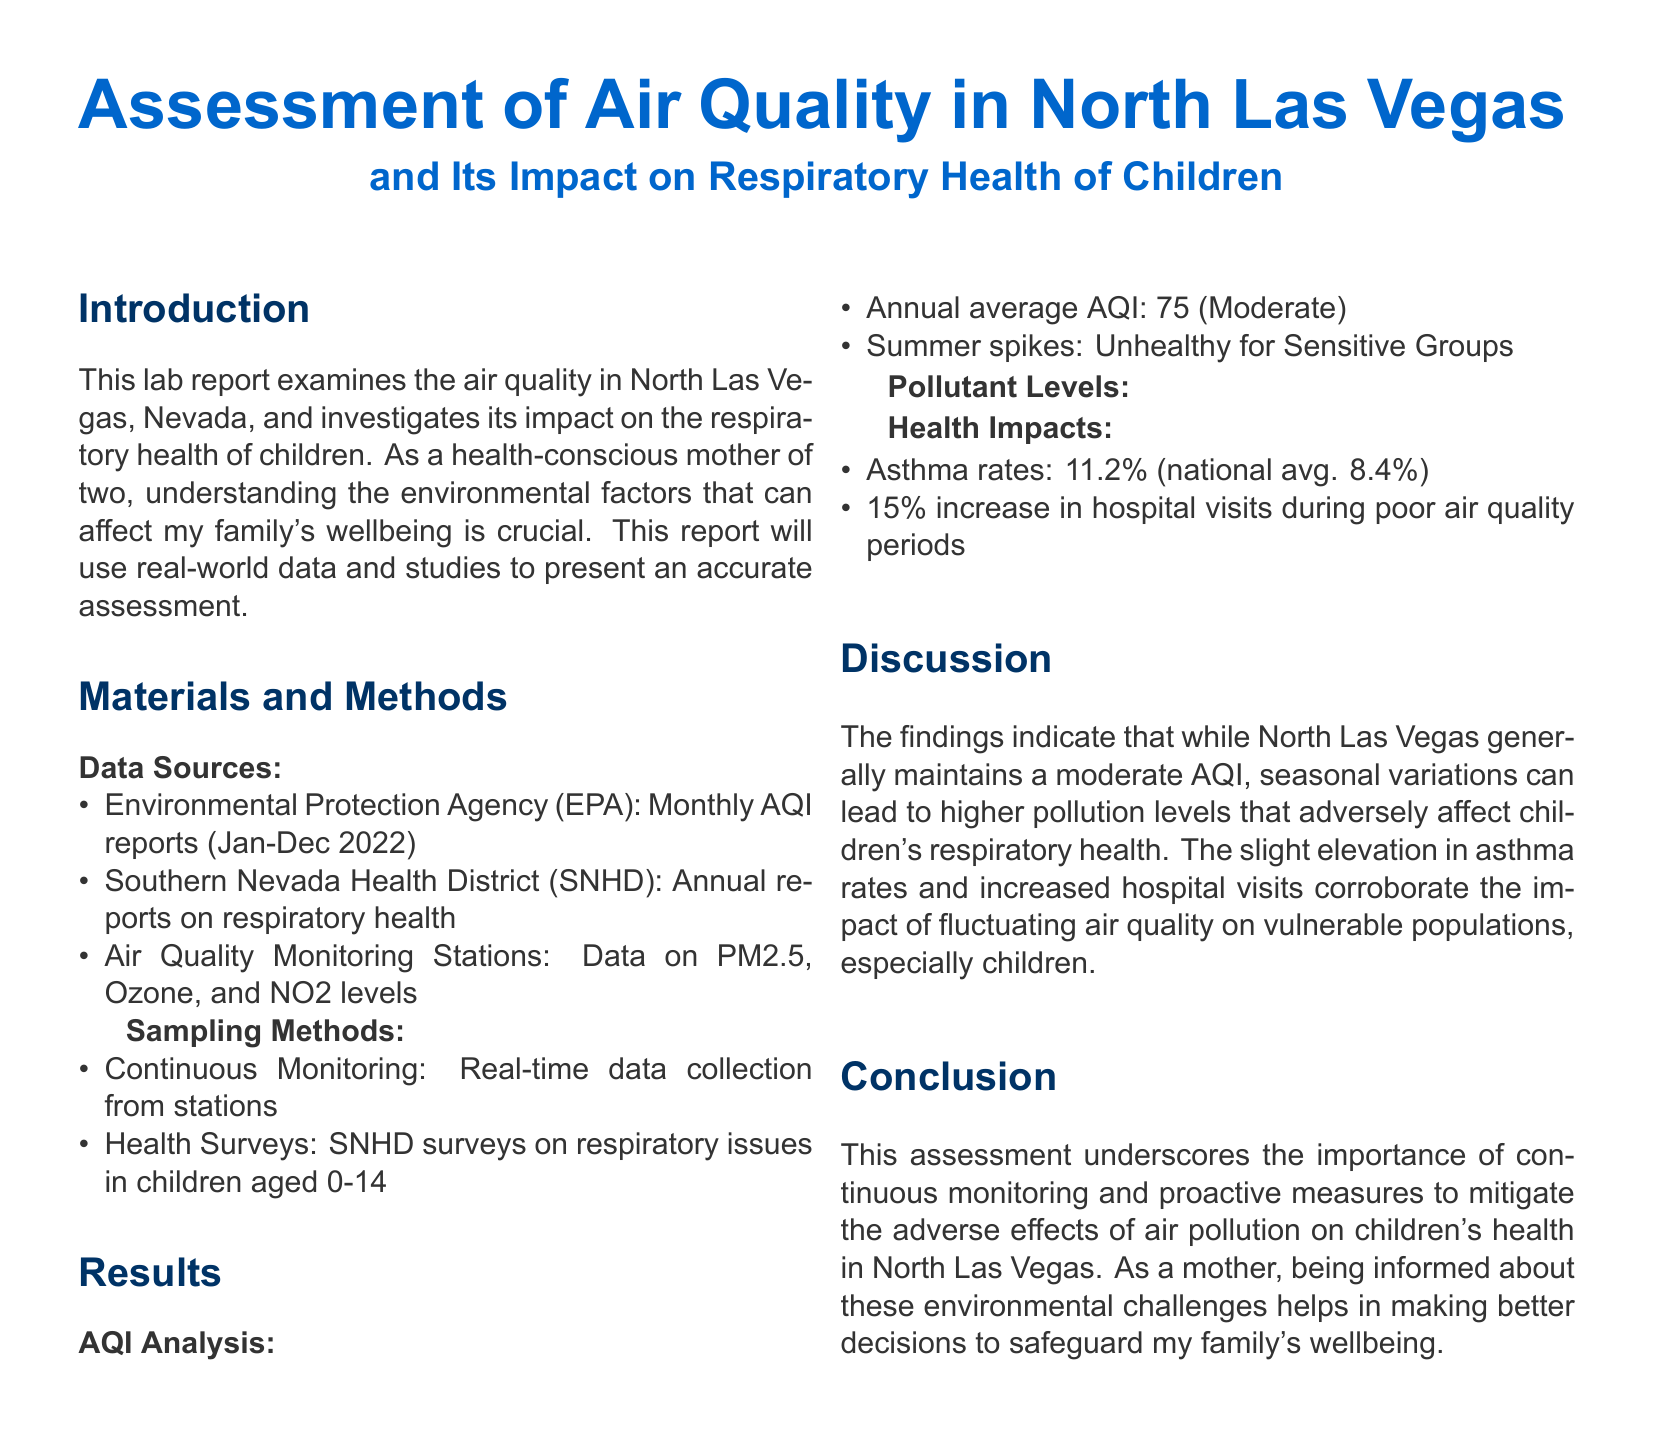what was the annual average AQI in North Las Vegas? The annual average AQI is the mean value derived from the monthly AQI reports, recorded as 75.
Answer: 75 what is the PM2.5 annual average level? The PM2.5 level is presented as 12.3 µg/m³ according to the table of pollutant levels.
Answer: 12.3 µg/m³ what percentage of children experience asthma in North Las Vegas? The asthma rate is reported as 11.2%, which is identified in the health impacts section.
Answer: 11.2% which pollutant exceeds EPA standards in summer? The ozone level is indicated as exceeding EPA standards during summer months in the pollutant levels section.
Answer: Ozone what is the percentage increase in hospital visits during poor air quality? The report states that there is a 15% increase in hospital visits during periods of poor air quality.
Answer: 15% what environmental organization provided the monthly AQI reports? The monthly AQI reports were provided by the Environmental Protection Agency.
Answer: Environmental Protection Agency how does the annual average AQI in North Las Vegas compare to the national average asthma rate? The comparison highlights that North Las Vegas has a higher asthma rate (11.2%) than the national average (8.4%), indicating a disparity in respiratory issues.
Answer: Higher what type of monitoring was conducted for the air quality assessment? Continuous monitoring is the method used for real-time data collection as mentioned in the sampling methods.
Answer: Continuous Monitoring what is the main conclusion of the report? The conclusion emphasizes the need for continuous monitoring and proactive measures for safeguarding children's health against air pollution.
Answer: Importance of continuous monitoring 